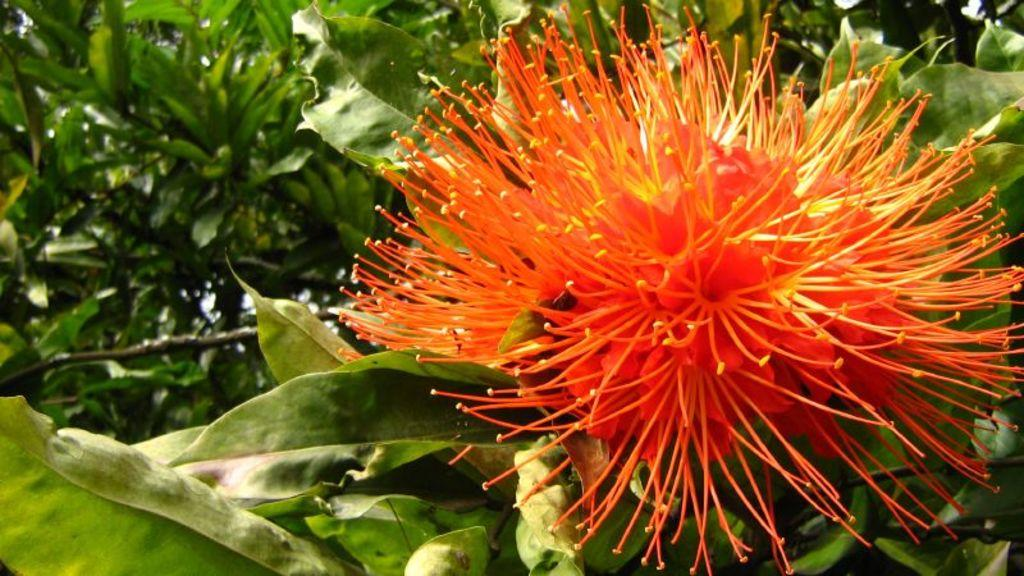What is the main subject of the image? There is a flower in the image. Can you describe the background of the image? There are plants in the background of the image. What type of carriage can be seen transporting a tiger in the image? There is no carriage or tiger present in the image; it features a flower and plants in the background. 